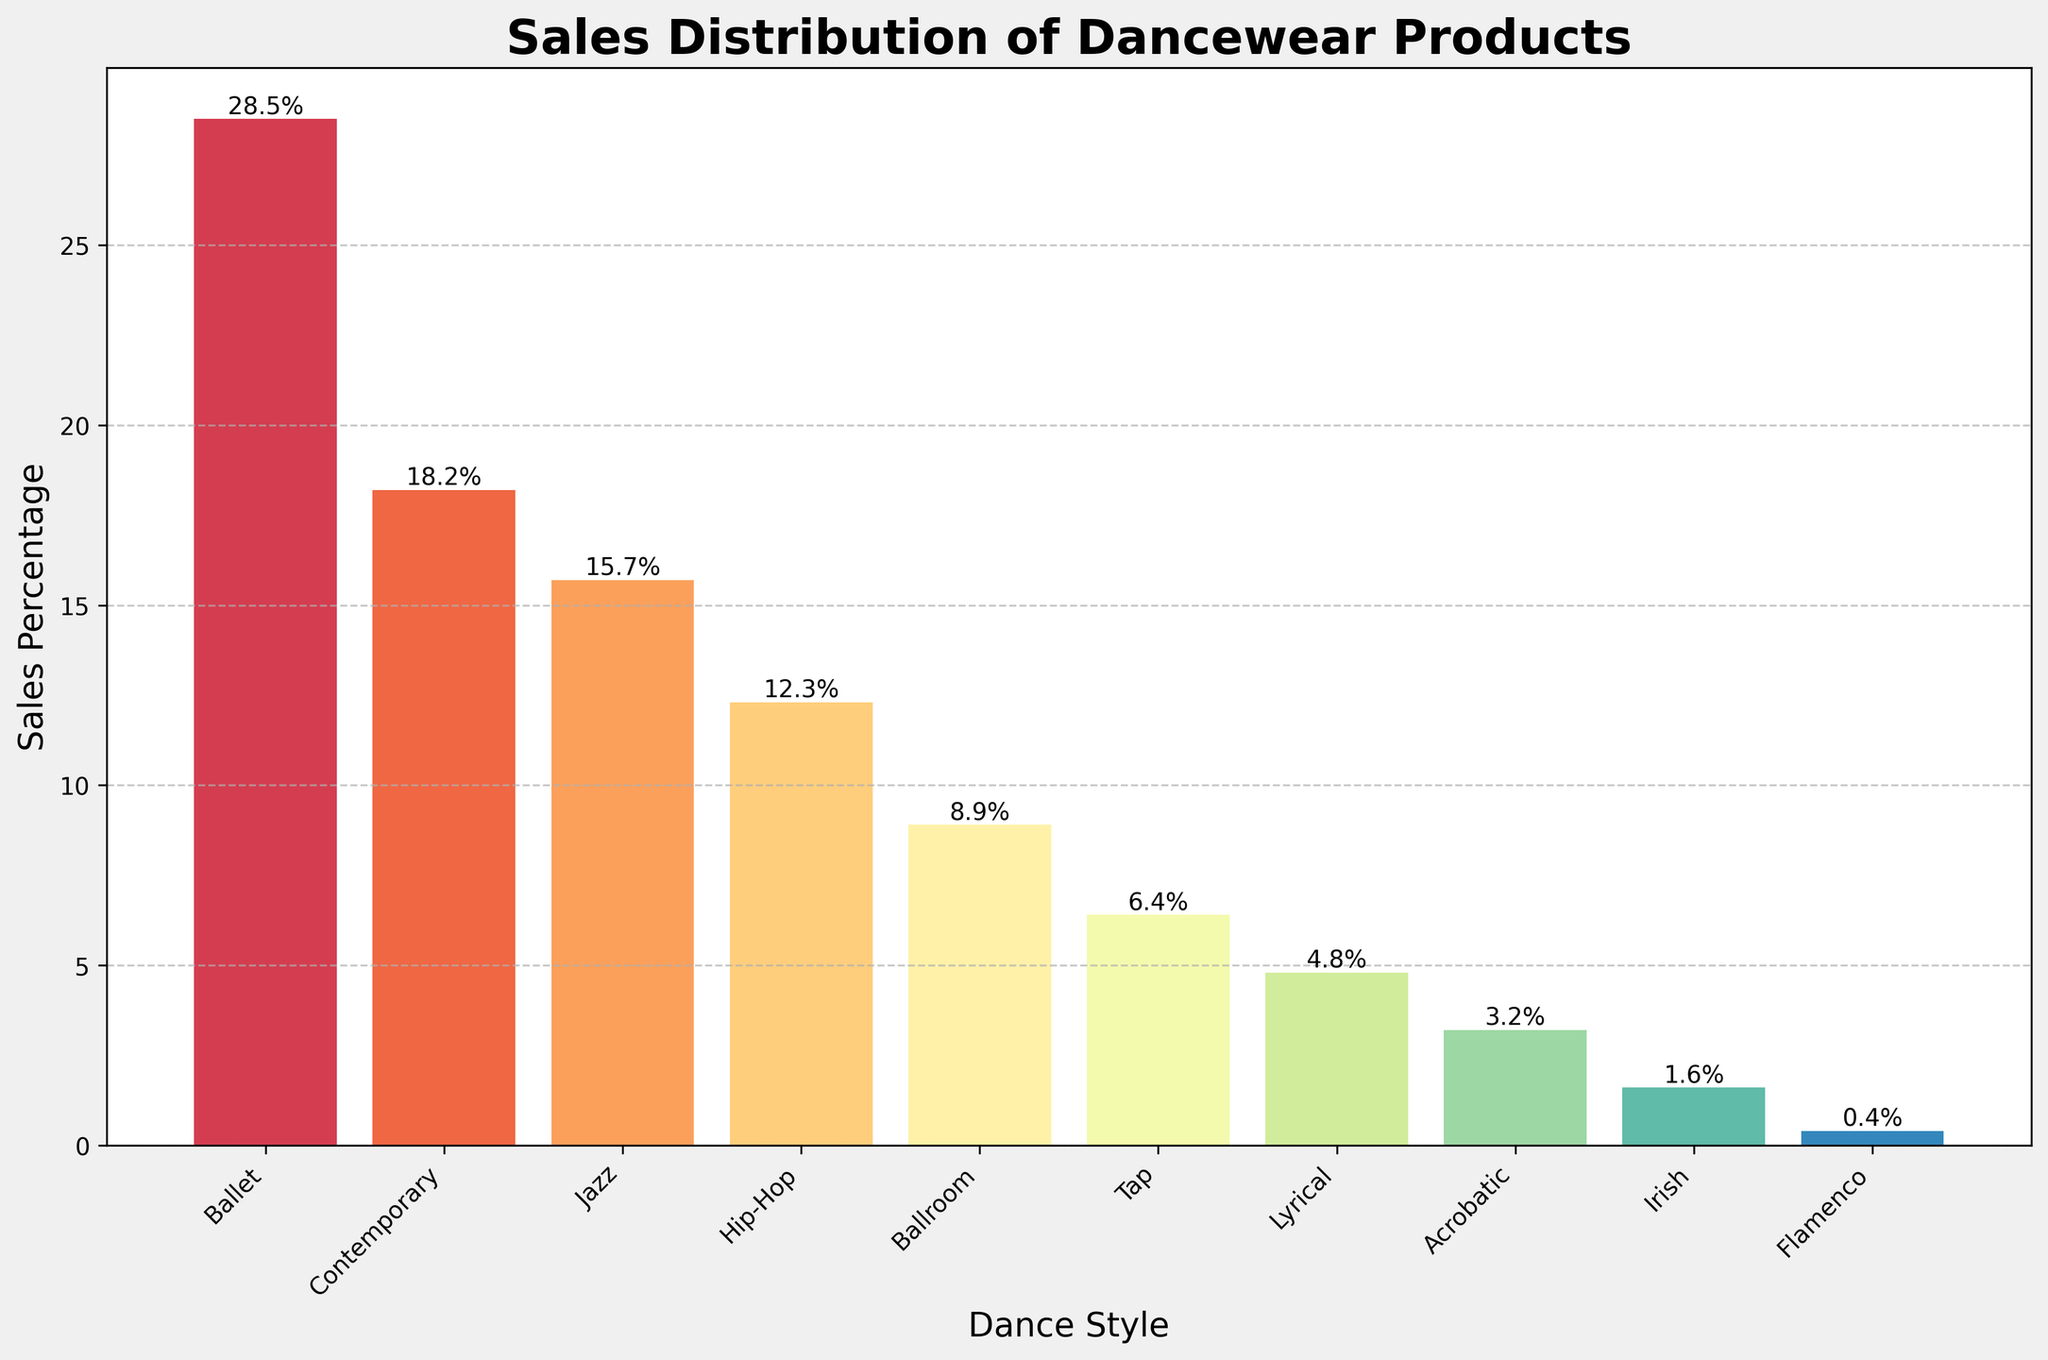What is the sales percentage for Ballet? The figure clearly shows the height of the Ballet bar, which corresponds to the sales percentage.
Answer: 28.5% Which dance style has the lowest sales percentage? By identifying the shortest bar in the figure, we can determine the dance style with the lowest sales percentage.
Answer: Flamenco What is the total sales percentage for Ballet and Contemporary combined? Add the sales percentages of Ballet and Contemporary, which are shown on top of their respective bars. 28.5% + 18.2% = 46.7%
Answer: 46.7% Is the sales percentage for Hip-Hop greater than for Jazz? Compare the heights of the bars for Hip-Hop and Jazz. The Jazz bar is taller, indicating a higher sales percentage.
Answer: No How much higher is the sales percentage of Ballet compared to Hip-Hop? Subtract the sales percentage for Hip-Hop from Ballet. 28.5% - 12.3% = 16.2%
Answer: 16.2% What is the average sales percentage of the three highest-selling dance styles? Identify the three tallest bars (Ballet, Contemporary, Jazz) and calculate the average. (28.5% + 18.2% + 15.7%) / 3 = 20.8%
Answer: 20.8% Which dance styles have a sales percentage less than 5%? Identify the bars with heights less than 5%, corresponding to their sales percentages.
Answer: Lyrical, Acrobatic, Irish, Flamenco Are there more dance styles with sales percentages above 10% or below 10%? Count the number of bars above and below the 10% sales percentage mark.
Answer: Below 10% What is the difference in sales percentage between Ballroom and Tap? Subtract the sales percentage of Tap from Ballroom. 8.9% - 6.4% = 2.5%
Answer: 2.5% 